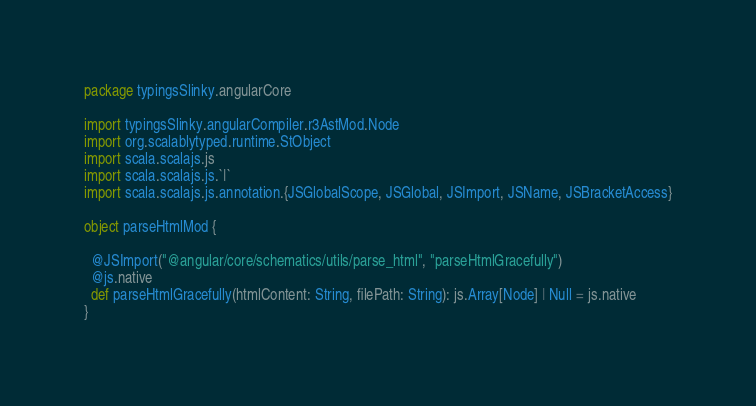Convert code to text. <code><loc_0><loc_0><loc_500><loc_500><_Scala_>package typingsSlinky.angularCore

import typingsSlinky.angularCompiler.r3AstMod.Node
import org.scalablytyped.runtime.StObject
import scala.scalajs.js
import scala.scalajs.js.`|`
import scala.scalajs.js.annotation.{JSGlobalScope, JSGlobal, JSImport, JSName, JSBracketAccess}

object parseHtmlMod {
  
  @JSImport("@angular/core/schematics/utils/parse_html", "parseHtmlGracefully")
  @js.native
  def parseHtmlGracefully(htmlContent: String, filePath: String): js.Array[Node] | Null = js.native
}
</code> 